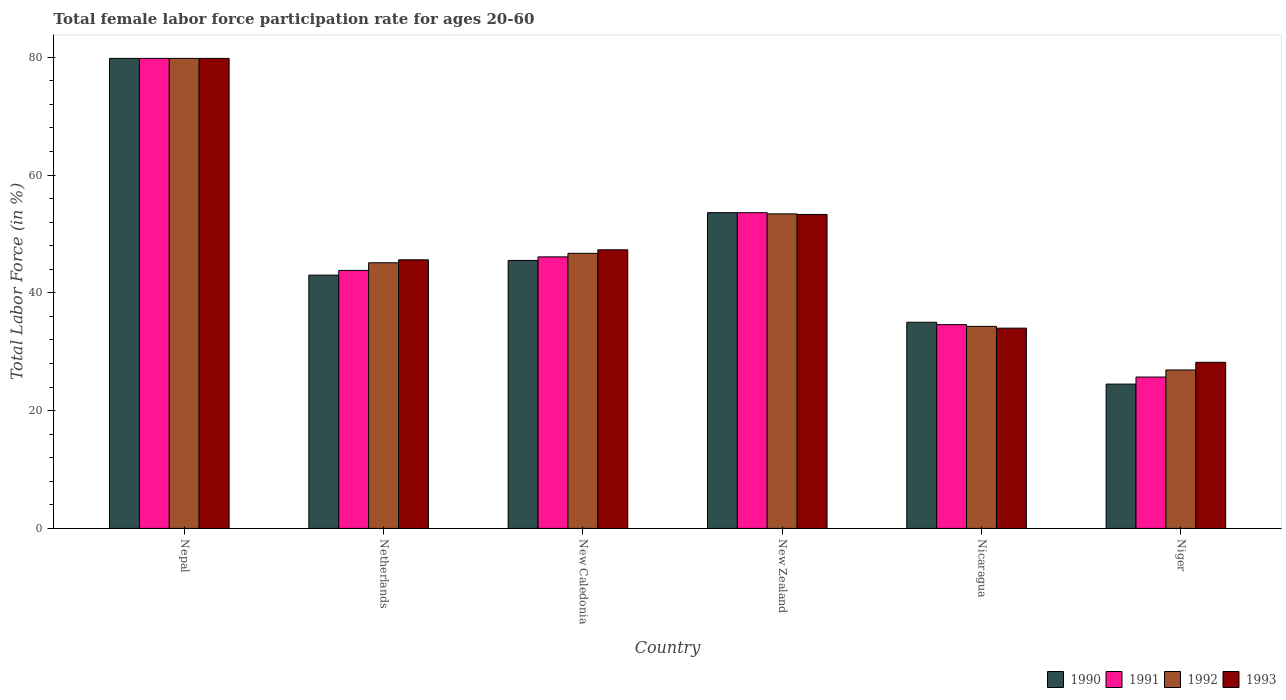How many groups of bars are there?
Keep it short and to the point. 6. Are the number of bars per tick equal to the number of legend labels?
Your response must be concise. Yes. Are the number of bars on each tick of the X-axis equal?
Provide a short and direct response. Yes. What is the label of the 6th group of bars from the left?
Offer a terse response. Niger. What is the female labor force participation rate in 1992 in New Caledonia?
Ensure brevity in your answer.  46.7. Across all countries, what is the maximum female labor force participation rate in 1990?
Keep it short and to the point. 79.8. Across all countries, what is the minimum female labor force participation rate in 1993?
Keep it short and to the point. 28.2. In which country was the female labor force participation rate in 1990 maximum?
Provide a succinct answer. Nepal. In which country was the female labor force participation rate in 1993 minimum?
Give a very brief answer. Niger. What is the total female labor force participation rate in 1993 in the graph?
Make the answer very short. 288.2. What is the difference between the female labor force participation rate in 1992 in Niger and the female labor force participation rate in 1993 in New Caledonia?
Your response must be concise. -20.4. What is the average female labor force participation rate in 1992 per country?
Your answer should be very brief. 47.7. What is the difference between the female labor force participation rate of/in 1993 and female labor force participation rate of/in 1992 in New Zealand?
Ensure brevity in your answer.  -0.1. What is the ratio of the female labor force participation rate in 1993 in Netherlands to that in Nicaragua?
Give a very brief answer. 1.34. Is the difference between the female labor force participation rate in 1993 in Nepal and New Zealand greater than the difference between the female labor force participation rate in 1992 in Nepal and New Zealand?
Provide a succinct answer. Yes. What is the difference between the highest and the second highest female labor force participation rate in 1993?
Your response must be concise. -6. What is the difference between the highest and the lowest female labor force participation rate in 1990?
Provide a succinct answer. 55.3. Is the sum of the female labor force participation rate in 1990 in Netherlands and Niger greater than the maximum female labor force participation rate in 1992 across all countries?
Ensure brevity in your answer.  No. What does the 1st bar from the left in Netherlands represents?
Keep it short and to the point. 1990. What does the 4th bar from the right in New Caledonia represents?
Your answer should be very brief. 1990. Is it the case that in every country, the sum of the female labor force participation rate in 1992 and female labor force participation rate in 1993 is greater than the female labor force participation rate in 1991?
Give a very brief answer. Yes. How many bars are there?
Offer a terse response. 24. Does the graph contain grids?
Your answer should be very brief. No. How many legend labels are there?
Provide a short and direct response. 4. How are the legend labels stacked?
Make the answer very short. Horizontal. What is the title of the graph?
Keep it short and to the point. Total female labor force participation rate for ages 20-60. Does "1973" appear as one of the legend labels in the graph?
Give a very brief answer. No. What is the label or title of the X-axis?
Offer a very short reply. Country. What is the Total Labor Force (in %) of 1990 in Nepal?
Your response must be concise. 79.8. What is the Total Labor Force (in %) in 1991 in Nepal?
Give a very brief answer. 79.8. What is the Total Labor Force (in %) in 1992 in Nepal?
Keep it short and to the point. 79.8. What is the Total Labor Force (in %) of 1993 in Nepal?
Your answer should be very brief. 79.8. What is the Total Labor Force (in %) of 1990 in Netherlands?
Ensure brevity in your answer.  43. What is the Total Labor Force (in %) in 1991 in Netherlands?
Ensure brevity in your answer.  43.8. What is the Total Labor Force (in %) of 1992 in Netherlands?
Provide a succinct answer. 45.1. What is the Total Labor Force (in %) of 1993 in Netherlands?
Your answer should be very brief. 45.6. What is the Total Labor Force (in %) of 1990 in New Caledonia?
Your response must be concise. 45.5. What is the Total Labor Force (in %) of 1991 in New Caledonia?
Your response must be concise. 46.1. What is the Total Labor Force (in %) of 1992 in New Caledonia?
Offer a terse response. 46.7. What is the Total Labor Force (in %) in 1993 in New Caledonia?
Offer a terse response. 47.3. What is the Total Labor Force (in %) of 1990 in New Zealand?
Provide a succinct answer. 53.6. What is the Total Labor Force (in %) of 1991 in New Zealand?
Offer a very short reply. 53.6. What is the Total Labor Force (in %) in 1992 in New Zealand?
Give a very brief answer. 53.4. What is the Total Labor Force (in %) in 1993 in New Zealand?
Your answer should be very brief. 53.3. What is the Total Labor Force (in %) of 1990 in Nicaragua?
Give a very brief answer. 35. What is the Total Labor Force (in %) in 1991 in Nicaragua?
Ensure brevity in your answer.  34.6. What is the Total Labor Force (in %) in 1992 in Nicaragua?
Give a very brief answer. 34.3. What is the Total Labor Force (in %) in 1993 in Nicaragua?
Your answer should be very brief. 34. What is the Total Labor Force (in %) of 1991 in Niger?
Ensure brevity in your answer.  25.7. What is the Total Labor Force (in %) of 1992 in Niger?
Provide a short and direct response. 26.9. What is the Total Labor Force (in %) in 1993 in Niger?
Ensure brevity in your answer.  28.2. Across all countries, what is the maximum Total Labor Force (in %) in 1990?
Your response must be concise. 79.8. Across all countries, what is the maximum Total Labor Force (in %) in 1991?
Give a very brief answer. 79.8. Across all countries, what is the maximum Total Labor Force (in %) in 1992?
Your answer should be compact. 79.8. Across all countries, what is the maximum Total Labor Force (in %) in 1993?
Provide a short and direct response. 79.8. Across all countries, what is the minimum Total Labor Force (in %) in 1991?
Make the answer very short. 25.7. Across all countries, what is the minimum Total Labor Force (in %) in 1992?
Provide a succinct answer. 26.9. Across all countries, what is the minimum Total Labor Force (in %) of 1993?
Make the answer very short. 28.2. What is the total Total Labor Force (in %) of 1990 in the graph?
Your answer should be very brief. 281.4. What is the total Total Labor Force (in %) in 1991 in the graph?
Provide a short and direct response. 283.6. What is the total Total Labor Force (in %) of 1992 in the graph?
Your response must be concise. 286.2. What is the total Total Labor Force (in %) of 1993 in the graph?
Provide a short and direct response. 288.2. What is the difference between the Total Labor Force (in %) of 1990 in Nepal and that in Netherlands?
Make the answer very short. 36.8. What is the difference between the Total Labor Force (in %) of 1992 in Nepal and that in Netherlands?
Provide a succinct answer. 34.7. What is the difference between the Total Labor Force (in %) in 1993 in Nepal and that in Netherlands?
Give a very brief answer. 34.2. What is the difference between the Total Labor Force (in %) of 1990 in Nepal and that in New Caledonia?
Your response must be concise. 34.3. What is the difference between the Total Labor Force (in %) in 1991 in Nepal and that in New Caledonia?
Ensure brevity in your answer.  33.7. What is the difference between the Total Labor Force (in %) of 1992 in Nepal and that in New Caledonia?
Your answer should be very brief. 33.1. What is the difference between the Total Labor Force (in %) in 1993 in Nepal and that in New Caledonia?
Give a very brief answer. 32.5. What is the difference between the Total Labor Force (in %) of 1990 in Nepal and that in New Zealand?
Offer a very short reply. 26.2. What is the difference between the Total Labor Force (in %) in 1991 in Nepal and that in New Zealand?
Offer a terse response. 26.2. What is the difference between the Total Labor Force (in %) in 1992 in Nepal and that in New Zealand?
Your response must be concise. 26.4. What is the difference between the Total Labor Force (in %) in 1993 in Nepal and that in New Zealand?
Ensure brevity in your answer.  26.5. What is the difference between the Total Labor Force (in %) in 1990 in Nepal and that in Nicaragua?
Offer a terse response. 44.8. What is the difference between the Total Labor Force (in %) in 1991 in Nepal and that in Nicaragua?
Your answer should be very brief. 45.2. What is the difference between the Total Labor Force (in %) in 1992 in Nepal and that in Nicaragua?
Make the answer very short. 45.5. What is the difference between the Total Labor Force (in %) of 1993 in Nepal and that in Nicaragua?
Provide a succinct answer. 45.8. What is the difference between the Total Labor Force (in %) of 1990 in Nepal and that in Niger?
Ensure brevity in your answer.  55.3. What is the difference between the Total Labor Force (in %) of 1991 in Nepal and that in Niger?
Keep it short and to the point. 54.1. What is the difference between the Total Labor Force (in %) in 1992 in Nepal and that in Niger?
Provide a succinct answer. 52.9. What is the difference between the Total Labor Force (in %) of 1993 in Nepal and that in Niger?
Offer a very short reply. 51.6. What is the difference between the Total Labor Force (in %) of 1990 in Netherlands and that in New Caledonia?
Your answer should be compact. -2.5. What is the difference between the Total Labor Force (in %) of 1992 in Netherlands and that in New Caledonia?
Make the answer very short. -1.6. What is the difference between the Total Labor Force (in %) of 1993 in Netherlands and that in New Caledonia?
Your answer should be compact. -1.7. What is the difference between the Total Labor Force (in %) of 1990 in Netherlands and that in New Zealand?
Offer a very short reply. -10.6. What is the difference between the Total Labor Force (in %) of 1991 in Netherlands and that in New Zealand?
Your response must be concise. -9.8. What is the difference between the Total Labor Force (in %) in 1992 in Netherlands and that in New Zealand?
Ensure brevity in your answer.  -8.3. What is the difference between the Total Labor Force (in %) of 1990 in Netherlands and that in Nicaragua?
Your answer should be compact. 8. What is the difference between the Total Labor Force (in %) of 1990 in Netherlands and that in Niger?
Your answer should be very brief. 18.5. What is the difference between the Total Labor Force (in %) in 1991 in Netherlands and that in Niger?
Offer a terse response. 18.1. What is the difference between the Total Labor Force (in %) in 1992 in Netherlands and that in Niger?
Give a very brief answer. 18.2. What is the difference between the Total Labor Force (in %) of 1993 in Netherlands and that in Niger?
Your answer should be very brief. 17.4. What is the difference between the Total Labor Force (in %) of 1990 in New Caledonia and that in New Zealand?
Ensure brevity in your answer.  -8.1. What is the difference between the Total Labor Force (in %) of 1991 in New Caledonia and that in New Zealand?
Ensure brevity in your answer.  -7.5. What is the difference between the Total Labor Force (in %) of 1992 in New Caledonia and that in New Zealand?
Keep it short and to the point. -6.7. What is the difference between the Total Labor Force (in %) of 1993 in New Caledonia and that in New Zealand?
Keep it short and to the point. -6. What is the difference between the Total Labor Force (in %) of 1991 in New Caledonia and that in Nicaragua?
Provide a short and direct response. 11.5. What is the difference between the Total Labor Force (in %) in 1991 in New Caledonia and that in Niger?
Keep it short and to the point. 20.4. What is the difference between the Total Labor Force (in %) in 1992 in New Caledonia and that in Niger?
Ensure brevity in your answer.  19.8. What is the difference between the Total Labor Force (in %) in 1993 in New Caledonia and that in Niger?
Provide a succinct answer. 19.1. What is the difference between the Total Labor Force (in %) of 1990 in New Zealand and that in Nicaragua?
Make the answer very short. 18.6. What is the difference between the Total Labor Force (in %) in 1991 in New Zealand and that in Nicaragua?
Your answer should be very brief. 19. What is the difference between the Total Labor Force (in %) of 1993 in New Zealand and that in Nicaragua?
Your answer should be compact. 19.3. What is the difference between the Total Labor Force (in %) of 1990 in New Zealand and that in Niger?
Your answer should be very brief. 29.1. What is the difference between the Total Labor Force (in %) of 1991 in New Zealand and that in Niger?
Provide a short and direct response. 27.9. What is the difference between the Total Labor Force (in %) of 1992 in New Zealand and that in Niger?
Give a very brief answer. 26.5. What is the difference between the Total Labor Force (in %) in 1993 in New Zealand and that in Niger?
Make the answer very short. 25.1. What is the difference between the Total Labor Force (in %) of 1991 in Nicaragua and that in Niger?
Provide a succinct answer. 8.9. What is the difference between the Total Labor Force (in %) of 1993 in Nicaragua and that in Niger?
Provide a succinct answer. 5.8. What is the difference between the Total Labor Force (in %) of 1990 in Nepal and the Total Labor Force (in %) of 1991 in Netherlands?
Keep it short and to the point. 36. What is the difference between the Total Labor Force (in %) in 1990 in Nepal and the Total Labor Force (in %) in 1992 in Netherlands?
Give a very brief answer. 34.7. What is the difference between the Total Labor Force (in %) of 1990 in Nepal and the Total Labor Force (in %) of 1993 in Netherlands?
Offer a very short reply. 34.2. What is the difference between the Total Labor Force (in %) of 1991 in Nepal and the Total Labor Force (in %) of 1992 in Netherlands?
Offer a terse response. 34.7. What is the difference between the Total Labor Force (in %) of 1991 in Nepal and the Total Labor Force (in %) of 1993 in Netherlands?
Provide a succinct answer. 34.2. What is the difference between the Total Labor Force (in %) of 1992 in Nepal and the Total Labor Force (in %) of 1993 in Netherlands?
Provide a succinct answer. 34.2. What is the difference between the Total Labor Force (in %) in 1990 in Nepal and the Total Labor Force (in %) in 1991 in New Caledonia?
Your answer should be compact. 33.7. What is the difference between the Total Labor Force (in %) of 1990 in Nepal and the Total Labor Force (in %) of 1992 in New Caledonia?
Your response must be concise. 33.1. What is the difference between the Total Labor Force (in %) of 1990 in Nepal and the Total Labor Force (in %) of 1993 in New Caledonia?
Offer a very short reply. 32.5. What is the difference between the Total Labor Force (in %) of 1991 in Nepal and the Total Labor Force (in %) of 1992 in New Caledonia?
Offer a terse response. 33.1. What is the difference between the Total Labor Force (in %) of 1991 in Nepal and the Total Labor Force (in %) of 1993 in New Caledonia?
Provide a succinct answer. 32.5. What is the difference between the Total Labor Force (in %) of 1992 in Nepal and the Total Labor Force (in %) of 1993 in New Caledonia?
Provide a succinct answer. 32.5. What is the difference between the Total Labor Force (in %) in 1990 in Nepal and the Total Labor Force (in %) in 1991 in New Zealand?
Make the answer very short. 26.2. What is the difference between the Total Labor Force (in %) of 1990 in Nepal and the Total Labor Force (in %) of 1992 in New Zealand?
Your answer should be compact. 26.4. What is the difference between the Total Labor Force (in %) in 1990 in Nepal and the Total Labor Force (in %) in 1993 in New Zealand?
Your answer should be very brief. 26.5. What is the difference between the Total Labor Force (in %) of 1991 in Nepal and the Total Labor Force (in %) of 1992 in New Zealand?
Offer a very short reply. 26.4. What is the difference between the Total Labor Force (in %) of 1992 in Nepal and the Total Labor Force (in %) of 1993 in New Zealand?
Your response must be concise. 26.5. What is the difference between the Total Labor Force (in %) of 1990 in Nepal and the Total Labor Force (in %) of 1991 in Nicaragua?
Your answer should be compact. 45.2. What is the difference between the Total Labor Force (in %) in 1990 in Nepal and the Total Labor Force (in %) in 1992 in Nicaragua?
Offer a very short reply. 45.5. What is the difference between the Total Labor Force (in %) of 1990 in Nepal and the Total Labor Force (in %) of 1993 in Nicaragua?
Give a very brief answer. 45.8. What is the difference between the Total Labor Force (in %) in 1991 in Nepal and the Total Labor Force (in %) in 1992 in Nicaragua?
Provide a short and direct response. 45.5. What is the difference between the Total Labor Force (in %) in 1991 in Nepal and the Total Labor Force (in %) in 1993 in Nicaragua?
Provide a succinct answer. 45.8. What is the difference between the Total Labor Force (in %) of 1992 in Nepal and the Total Labor Force (in %) of 1993 in Nicaragua?
Your answer should be very brief. 45.8. What is the difference between the Total Labor Force (in %) in 1990 in Nepal and the Total Labor Force (in %) in 1991 in Niger?
Make the answer very short. 54.1. What is the difference between the Total Labor Force (in %) of 1990 in Nepal and the Total Labor Force (in %) of 1992 in Niger?
Give a very brief answer. 52.9. What is the difference between the Total Labor Force (in %) of 1990 in Nepal and the Total Labor Force (in %) of 1993 in Niger?
Keep it short and to the point. 51.6. What is the difference between the Total Labor Force (in %) of 1991 in Nepal and the Total Labor Force (in %) of 1992 in Niger?
Provide a succinct answer. 52.9. What is the difference between the Total Labor Force (in %) in 1991 in Nepal and the Total Labor Force (in %) in 1993 in Niger?
Ensure brevity in your answer.  51.6. What is the difference between the Total Labor Force (in %) of 1992 in Nepal and the Total Labor Force (in %) of 1993 in Niger?
Keep it short and to the point. 51.6. What is the difference between the Total Labor Force (in %) of 1990 in Netherlands and the Total Labor Force (in %) of 1993 in New Caledonia?
Offer a very short reply. -4.3. What is the difference between the Total Labor Force (in %) of 1992 in Netherlands and the Total Labor Force (in %) of 1993 in New Caledonia?
Offer a terse response. -2.2. What is the difference between the Total Labor Force (in %) of 1990 in Netherlands and the Total Labor Force (in %) of 1993 in New Zealand?
Keep it short and to the point. -10.3. What is the difference between the Total Labor Force (in %) in 1991 in Netherlands and the Total Labor Force (in %) in 1992 in New Zealand?
Offer a terse response. -9.6. What is the difference between the Total Labor Force (in %) in 1992 in Netherlands and the Total Labor Force (in %) in 1993 in New Zealand?
Your answer should be very brief. -8.2. What is the difference between the Total Labor Force (in %) in 1991 in Netherlands and the Total Labor Force (in %) in 1992 in Nicaragua?
Offer a very short reply. 9.5. What is the difference between the Total Labor Force (in %) of 1991 in Netherlands and the Total Labor Force (in %) of 1993 in Nicaragua?
Your response must be concise. 9.8. What is the difference between the Total Labor Force (in %) in 1990 in Netherlands and the Total Labor Force (in %) in 1992 in Niger?
Your answer should be very brief. 16.1. What is the difference between the Total Labor Force (in %) of 1990 in New Caledonia and the Total Labor Force (in %) of 1991 in New Zealand?
Your answer should be very brief. -8.1. What is the difference between the Total Labor Force (in %) in 1991 in New Caledonia and the Total Labor Force (in %) in 1993 in New Zealand?
Offer a very short reply. -7.2. What is the difference between the Total Labor Force (in %) in 1992 in New Caledonia and the Total Labor Force (in %) in 1993 in New Zealand?
Make the answer very short. -6.6. What is the difference between the Total Labor Force (in %) of 1991 in New Caledonia and the Total Labor Force (in %) of 1992 in Nicaragua?
Your answer should be very brief. 11.8. What is the difference between the Total Labor Force (in %) of 1991 in New Caledonia and the Total Labor Force (in %) of 1993 in Nicaragua?
Your response must be concise. 12.1. What is the difference between the Total Labor Force (in %) of 1992 in New Caledonia and the Total Labor Force (in %) of 1993 in Nicaragua?
Provide a succinct answer. 12.7. What is the difference between the Total Labor Force (in %) in 1990 in New Caledonia and the Total Labor Force (in %) in 1991 in Niger?
Provide a succinct answer. 19.8. What is the difference between the Total Labor Force (in %) in 1990 in New Caledonia and the Total Labor Force (in %) in 1992 in Niger?
Keep it short and to the point. 18.6. What is the difference between the Total Labor Force (in %) in 1990 in New Caledonia and the Total Labor Force (in %) in 1993 in Niger?
Provide a short and direct response. 17.3. What is the difference between the Total Labor Force (in %) in 1990 in New Zealand and the Total Labor Force (in %) in 1991 in Nicaragua?
Keep it short and to the point. 19. What is the difference between the Total Labor Force (in %) of 1990 in New Zealand and the Total Labor Force (in %) of 1992 in Nicaragua?
Offer a very short reply. 19.3. What is the difference between the Total Labor Force (in %) in 1990 in New Zealand and the Total Labor Force (in %) in 1993 in Nicaragua?
Your answer should be very brief. 19.6. What is the difference between the Total Labor Force (in %) of 1991 in New Zealand and the Total Labor Force (in %) of 1992 in Nicaragua?
Ensure brevity in your answer.  19.3. What is the difference between the Total Labor Force (in %) in 1991 in New Zealand and the Total Labor Force (in %) in 1993 in Nicaragua?
Give a very brief answer. 19.6. What is the difference between the Total Labor Force (in %) in 1992 in New Zealand and the Total Labor Force (in %) in 1993 in Nicaragua?
Offer a very short reply. 19.4. What is the difference between the Total Labor Force (in %) of 1990 in New Zealand and the Total Labor Force (in %) of 1991 in Niger?
Provide a succinct answer. 27.9. What is the difference between the Total Labor Force (in %) of 1990 in New Zealand and the Total Labor Force (in %) of 1992 in Niger?
Your answer should be very brief. 26.7. What is the difference between the Total Labor Force (in %) in 1990 in New Zealand and the Total Labor Force (in %) in 1993 in Niger?
Your answer should be compact. 25.4. What is the difference between the Total Labor Force (in %) of 1991 in New Zealand and the Total Labor Force (in %) of 1992 in Niger?
Your answer should be compact. 26.7. What is the difference between the Total Labor Force (in %) in 1991 in New Zealand and the Total Labor Force (in %) in 1993 in Niger?
Give a very brief answer. 25.4. What is the difference between the Total Labor Force (in %) in 1992 in New Zealand and the Total Labor Force (in %) in 1993 in Niger?
Ensure brevity in your answer.  25.2. What is the difference between the Total Labor Force (in %) of 1990 in Nicaragua and the Total Labor Force (in %) of 1991 in Niger?
Provide a short and direct response. 9.3. What is the difference between the Total Labor Force (in %) of 1990 in Nicaragua and the Total Labor Force (in %) of 1992 in Niger?
Keep it short and to the point. 8.1. What is the difference between the Total Labor Force (in %) in 1992 in Nicaragua and the Total Labor Force (in %) in 1993 in Niger?
Offer a terse response. 6.1. What is the average Total Labor Force (in %) of 1990 per country?
Ensure brevity in your answer.  46.9. What is the average Total Labor Force (in %) of 1991 per country?
Offer a very short reply. 47.27. What is the average Total Labor Force (in %) in 1992 per country?
Make the answer very short. 47.7. What is the average Total Labor Force (in %) in 1993 per country?
Keep it short and to the point. 48.03. What is the difference between the Total Labor Force (in %) in 1990 and Total Labor Force (in %) in 1991 in Nepal?
Provide a succinct answer. 0. What is the difference between the Total Labor Force (in %) of 1990 and Total Labor Force (in %) of 1993 in Nepal?
Your answer should be very brief. 0. What is the difference between the Total Labor Force (in %) of 1991 and Total Labor Force (in %) of 1992 in Nepal?
Offer a terse response. 0. What is the difference between the Total Labor Force (in %) in 1991 and Total Labor Force (in %) in 1993 in Nepal?
Your answer should be very brief. 0. What is the difference between the Total Labor Force (in %) of 1992 and Total Labor Force (in %) of 1993 in Netherlands?
Provide a short and direct response. -0.5. What is the difference between the Total Labor Force (in %) of 1990 and Total Labor Force (in %) of 1991 in New Caledonia?
Keep it short and to the point. -0.6. What is the difference between the Total Labor Force (in %) of 1990 and Total Labor Force (in %) of 1992 in New Caledonia?
Provide a succinct answer. -1.2. What is the difference between the Total Labor Force (in %) of 1991 and Total Labor Force (in %) of 1993 in New Caledonia?
Your response must be concise. -1.2. What is the difference between the Total Labor Force (in %) in 1990 and Total Labor Force (in %) in 1991 in New Zealand?
Provide a short and direct response. 0. What is the difference between the Total Labor Force (in %) in 1991 and Total Labor Force (in %) in 1992 in New Zealand?
Offer a very short reply. 0.2. What is the difference between the Total Labor Force (in %) in 1991 and Total Labor Force (in %) in 1993 in New Zealand?
Provide a short and direct response. 0.3. What is the difference between the Total Labor Force (in %) in 1992 and Total Labor Force (in %) in 1993 in New Zealand?
Provide a succinct answer. 0.1. What is the difference between the Total Labor Force (in %) of 1991 and Total Labor Force (in %) of 1992 in Nicaragua?
Your response must be concise. 0.3. What is the difference between the Total Labor Force (in %) of 1991 and Total Labor Force (in %) of 1993 in Nicaragua?
Your answer should be compact. 0.6. What is the difference between the Total Labor Force (in %) in 1990 and Total Labor Force (in %) in 1992 in Niger?
Your answer should be very brief. -2.4. What is the difference between the Total Labor Force (in %) of 1990 and Total Labor Force (in %) of 1993 in Niger?
Make the answer very short. -3.7. What is the difference between the Total Labor Force (in %) in 1991 and Total Labor Force (in %) in 1992 in Niger?
Keep it short and to the point. -1.2. What is the difference between the Total Labor Force (in %) of 1991 and Total Labor Force (in %) of 1993 in Niger?
Provide a short and direct response. -2.5. What is the difference between the Total Labor Force (in %) of 1992 and Total Labor Force (in %) of 1993 in Niger?
Offer a terse response. -1.3. What is the ratio of the Total Labor Force (in %) of 1990 in Nepal to that in Netherlands?
Provide a succinct answer. 1.86. What is the ratio of the Total Labor Force (in %) in 1991 in Nepal to that in Netherlands?
Make the answer very short. 1.82. What is the ratio of the Total Labor Force (in %) in 1992 in Nepal to that in Netherlands?
Your answer should be compact. 1.77. What is the ratio of the Total Labor Force (in %) of 1990 in Nepal to that in New Caledonia?
Make the answer very short. 1.75. What is the ratio of the Total Labor Force (in %) of 1991 in Nepal to that in New Caledonia?
Keep it short and to the point. 1.73. What is the ratio of the Total Labor Force (in %) in 1992 in Nepal to that in New Caledonia?
Give a very brief answer. 1.71. What is the ratio of the Total Labor Force (in %) in 1993 in Nepal to that in New Caledonia?
Give a very brief answer. 1.69. What is the ratio of the Total Labor Force (in %) in 1990 in Nepal to that in New Zealand?
Provide a succinct answer. 1.49. What is the ratio of the Total Labor Force (in %) of 1991 in Nepal to that in New Zealand?
Offer a very short reply. 1.49. What is the ratio of the Total Labor Force (in %) in 1992 in Nepal to that in New Zealand?
Provide a short and direct response. 1.49. What is the ratio of the Total Labor Force (in %) of 1993 in Nepal to that in New Zealand?
Make the answer very short. 1.5. What is the ratio of the Total Labor Force (in %) of 1990 in Nepal to that in Nicaragua?
Offer a very short reply. 2.28. What is the ratio of the Total Labor Force (in %) of 1991 in Nepal to that in Nicaragua?
Keep it short and to the point. 2.31. What is the ratio of the Total Labor Force (in %) in 1992 in Nepal to that in Nicaragua?
Your response must be concise. 2.33. What is the ratio of the Total Labor Force (in %) in 1993 in Nepal to that in Nicaragua?
Offer a very short reply. 2.35. What is the ratio of the Total Labor Force (in %) of 1990 in Nepal to that in Niger?
Your answer should be very brief. 3.26. What is the ratio of the Total Labor Force (in %) in 1991 in Nepal to that in Niger?
Your answer should be compact. 3.11. What is the ratio of the Total Labor Force (in %) of 1992 in Nepal to that in Niger?
Keep it short and to the point. 2.97. What is the ratio of the Total Labor Force (in %) of 1993 in Nepal to that in Niger?
Give a very brief answer. 2.83. What is the ratio of the Total Labor Force (in %) of 1990 in Netherlands to that in New Caledonia?
Your response must be concise. 0.95. What is the ratio of the Total Labor Force (in %) of 1991 in Netherlands to that in New Caledonia?
Make the answer very short. 0.95. What is the ratio of the Total Labor Force (in %) in 1992 in Netherlands to that in New Caledonia?
Your response must be concise. 0.97. What is the ratio of the Total Labor Force (in %) of 1993 in Netherlands to that in New Caledonia?
Offer a very short reply. 0.96. What is the ratio of the Total Labor Force (in %) in 1990 in Netherlands to that in New Zealand?
Make the answer very short. 0.8. What is the ratio of the Total Labor Force (in %) in 1991 in Netherlands to that in New Zealand?
Your answer should be very brief. 0.82. What is the ratio of the Total Labor Force (in %) in 1992 in Netherlands to that in New Zealand?
Your answer should be very brief. 0.84. What is the ratio of the Total Labor Force (in %) of 1993 in Netherlands to that in New Zealand?
Offer a very short reply. 0.86. What is the ratio of the Total Labor Force (in %) in 1990 in Netherlands to that in Nicaragua?
Keep it short and to the point. 1.23. What is the ratio of the Total Labor Force (in %) of 1991 in Netherlands to that in Nicaragua?
Your response must be concise. 1.27. What is the ratio of the Total Labor Force (in %) of 1992 in Netherlands to that in Nicaragua?
Offer a very short reply. 1.31. What is the ratio of the Total Labor Force (in %) of 1993 in Netherlands to that in Nicaragua?
Offer a very short reply. 1.34. What is the ratio of the Total Labor Force (in %) in 1990 in Netherlands to that in Niger?
Provide a short and direct response. 1.76. What is the ratio of the Total Labor Force (in %) of 1991 in Netherlands to that in Niger?
Give a very brief answer. 1.7. What is the ratio of the Total Labor Force (in %) of 1992 in Netherlands to that in Niger?
Keep it short and to the point. 1.68. What is the ratio of the Total Labor Force (in %) of 1993 in Netherlands to that in Niger?
Make the answer very short. 1.62. What is the ratio of the Total Labor Force (in %) of 1990 in New Caledonia to that in New Zealand?
Offer a terse response. 0.85. What is the ratio of the Total Labor Force (in %) of 1991 in New Caledonia to that in New Zealand?
Offer a very short reply. 0.86. What is the ratio of the Total Labor Force (in %) of 1992 in New Caledonia to that in New Zealand?
Your answer should be compact. 0.87. What is the ratio of the Total Labor Force (in %) in 1993 in New Caledonia to that in New Zealand?
Provide a succinct answer. 0.89. What is the ratio of the Total Labor Force (in %) in 1990 in New Caledonia to that in Nicaragua?
Make the answer very short. 1.3. What is the ratio of the Total Labor Force (in %) in 1991 in New Caledonia to that in Nicaragua?
Give a very brief answer. 1.33. What is the ratio of the Total Labor Force (in %) of 1992 in New Caledonia to that in Nicaragua?
Your response must be concise. 1.36. What is the ratio of the Total Labor Force (in %) in 1993 in New Caledonia to that in Nicaragua?
Provide a short and direct response. 1.39. What is the ratio of the Total Labor Force (in %) of 1990 in New Caledonia to that in Niger?
Give a very brief answer. 1.86. What is the ratio of the Total Labor Force (in %) of 1991 in New Caledonia to that in Niger?
Ensure brevity in your answer.  1.79. What is the ratio of the Total Labor Force (in %) in 1992 in New Caledonia to that in Niger?
Provide a succinct answer. 1.74. What is the ratio of the Total Labor Force (in %) of 1993 in New Caledonia to that in Niger?
Your response must be concise. 1.68. What is the ratio of the Total Labor Force (in %) of 1990 in New Zealand to that in Nicaragua?
Provide a short and direct response. 1.53. What is the ratio of the Total Labor Force (in %) of 1991 in New Zealand to that in Nicaragua?
Make the answer very short. 1.55. What is the ratio of the Total Labor Force (in %) in 1992 in New Zealand to that in Nicaragua?
Your answer should be compact. 1.56. What is the ratio of the Total Labor Force (in %) in 1993 in New Zealand to that in Nicaragua?
Ensure brevity in your answer.  1.57. What is the ratio of the Total Labor Force (in %) in 1990 in New Zealand to that in Niger?
Provide a short and direct response. 2.19. What is the ratio of the Total Labor Force (in %) in 1991 in New Zealand to that in Niger?
Your answer should be very brief. 2.09. What is the ratio of the Total Labor Force (in %) in 1992 in New Zealand to that in Niger?
Your answer should be compact. 1.99. What is the ratio of the Total Labor Force (in %) of 1993 in New Zealand to that in Niger?
Your response must be concise. 1.89. What is the ratio of the Total Labor Force (in %) of 1990 in Nicaragua to that in Niger?
Your answer should be compact. 1.43. What is the ratio of the Total Labor Force (in %) in 1991 in Nicaragua to that in Niger?
Your response must be concise. 1.35. What is the ratio of the Total Labor Force (in %) in 1992 in Nicaragua to that in Niger?
Offer a very short reply. 1.28. What is the ratio of the Total Labor Force (in %) in 1993 in Nicaragua to that in Niger?
Give a very brief answer. 1.21. What is the difference between the highest and the second highest Total Labor Force (in %) of 1990?
Provide a short and direct response. 26.2. What is the difference between the highest and the second highest Total Labor Force (in %) of 1991?
Keep it short and to the point. 26.2. What is the difference between the highest and the second highest Total Labor Force (in %) of 1992?
Offer a very short reply. 26.4. What is the difference between the highest and the second highest Total Labor Force (in %) in 1993?
Make the answer very short. 26.5. What is the difference between the highest and the lowest Total Labor Force (in %) of 1990?
Give a very brief answer. 55.3. What is the difference between the highest and the lowest Total Labor Force (in %) in 1991?
Ensure brevity in your answer.  54.1. What is the difference between the highest and the lowest Total Labor Force (in %) in 1992?
Your response must be concise. 52.9. What is the difference between the highest and the lowest Total Labor Force (in %) of 1993?
Provide a short and direct response. 51.6. 